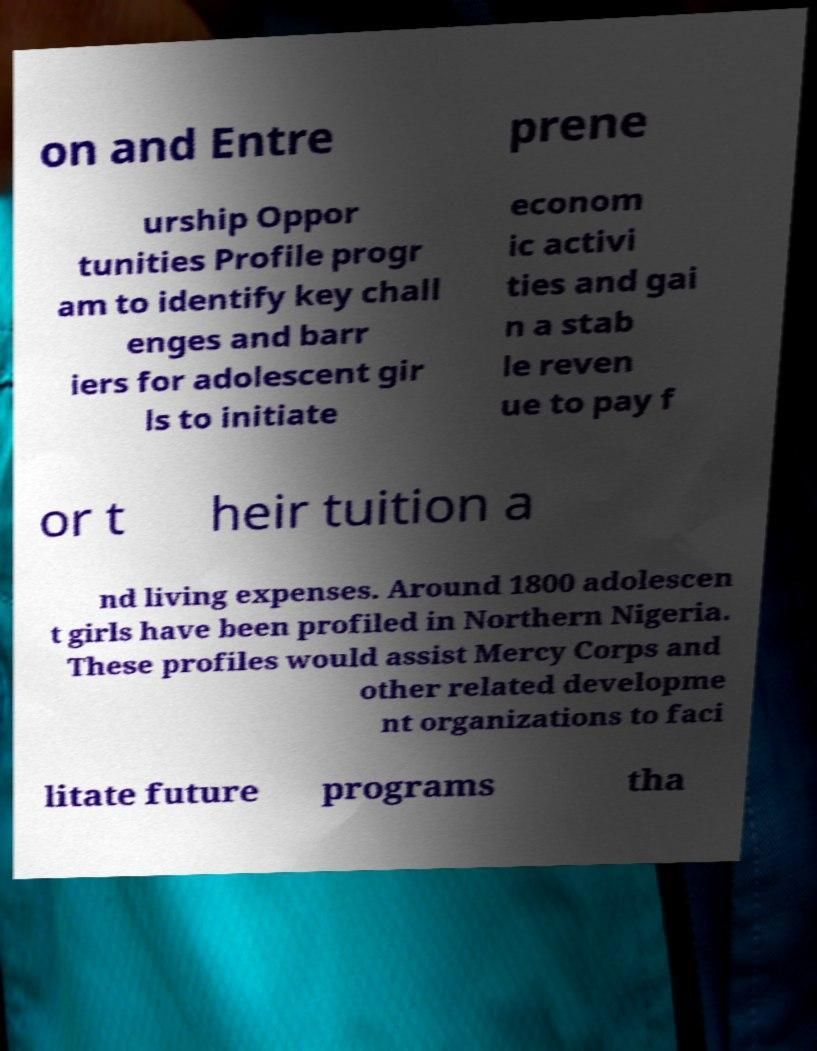Please identify and transcribe the text found in this image. on and Entre prene urship Oppor tunities Profile progr am to identify key chall enges and barr iers for adolescent gir ls to initiate econom ic activi ties and gai n a stab le reven ue to pay f or t heir tuition a nd living expenses. Around 1800 adolescen t girls have been profiled in Northern Nigeria. These profiles would assist Mercy Corps and other related developme nt organizations to faci litate future programs tha 